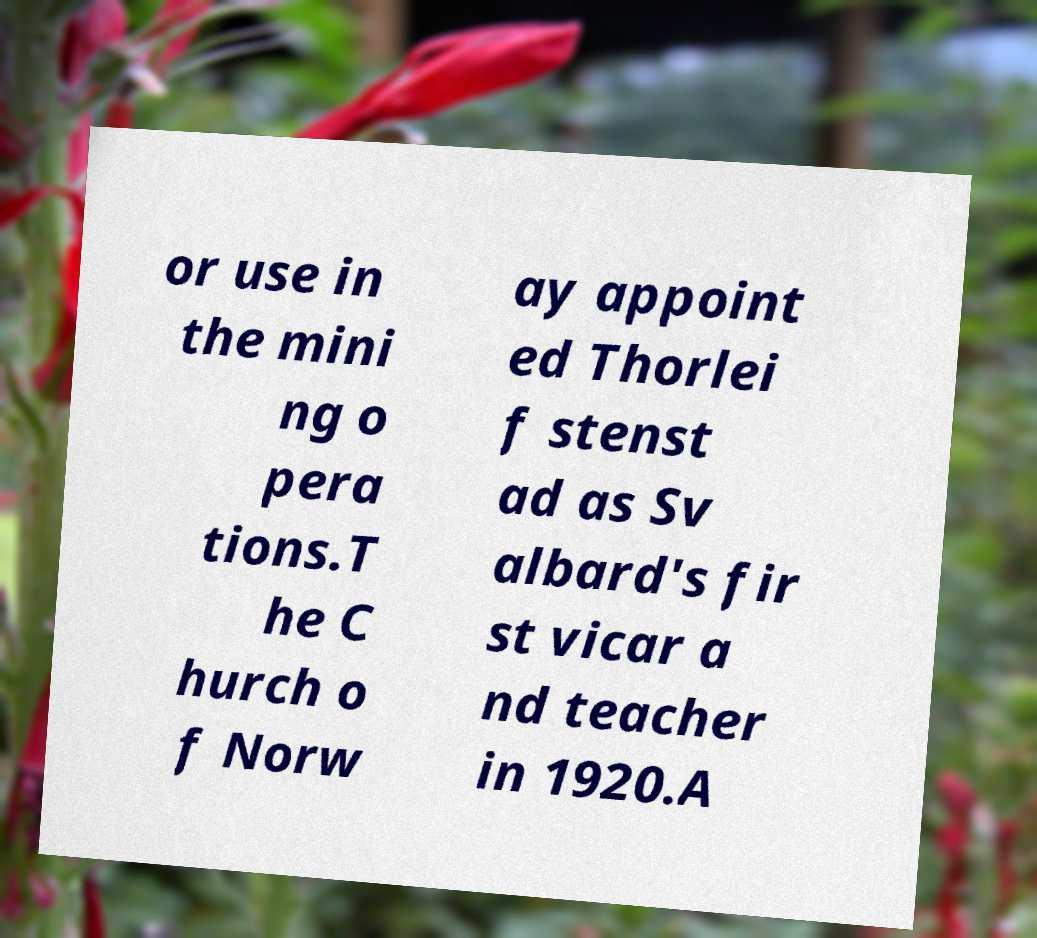What messages or text are displayed in this image? I need them in a readable, typed format. or use in the mini ng o pera tions.T he C hurch o f Norw ay appoint ed Thorlei f stenst ad as Sv albard's fir st vicar a nd teacher in 1920.A 